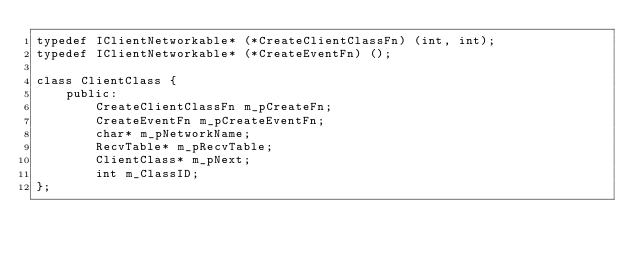<code> <loc_0><loc_0><loc_500><loc_500><_C++_>typedef IClientNetworkable* (*CreateClientClassFn) (int, int);
typedef IClientNetworkable* (*CreateEventFn) ();

class ClientClass {
	public:
		CreateClientClassFn m_pCreateFn;
		CreateEventFn m_pCreateEventFn;
		char* m_pNetworkName;
		RecvTable* m_pRecvTable;
		ClientClass* m_pNext;
		int m_ClassID;
};</code> 